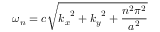Convert formula to latex. <formula><loc_0><loc_0><loc_500><loc_500>\omega _ { n } = c { \sqrt { { k _ { x } } ^ { 2 } + { k _ { y } } ^ { 2 } + { \frac { n ^ { 2 } \pi ^ { 2 } } { a ^ { 2 } } } } }</formula> 